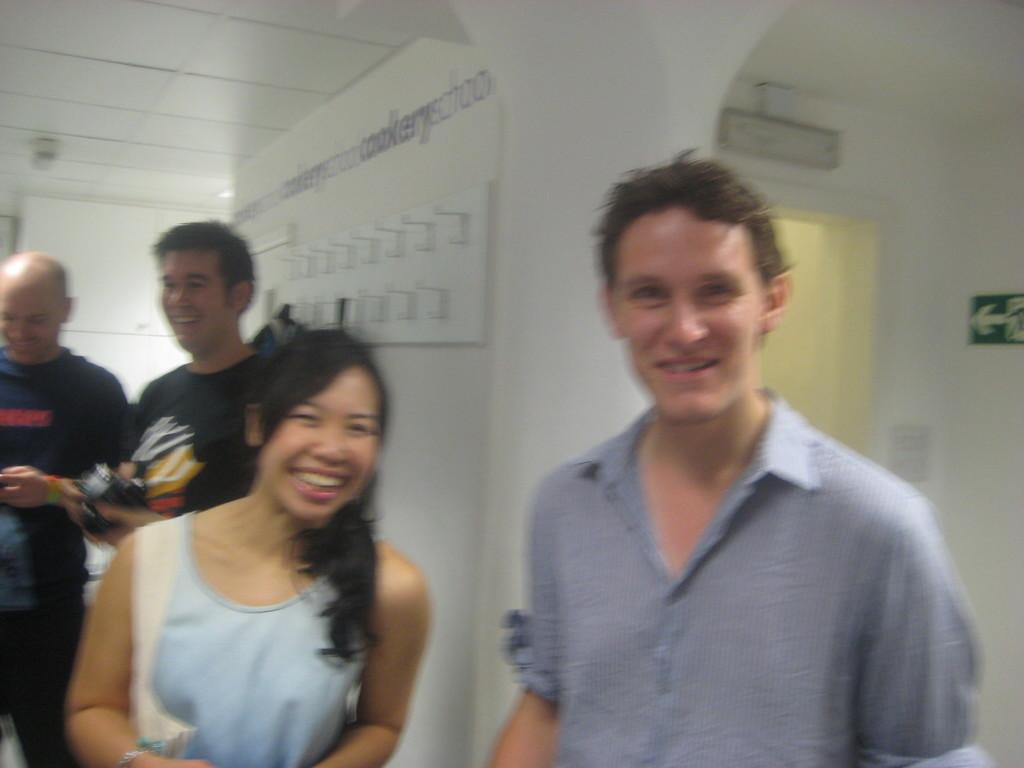How many people are in the image? There are four persons in the image. What is the facial expression of the people in the image? The persons are smiling. What can be seen in the background of the image? There is a wall and a board in the background of the image. What type of haircut does the person on the left have in the image? There is no information about haircuts in the image, as the focus is on the number of persons and their facial expressions. 